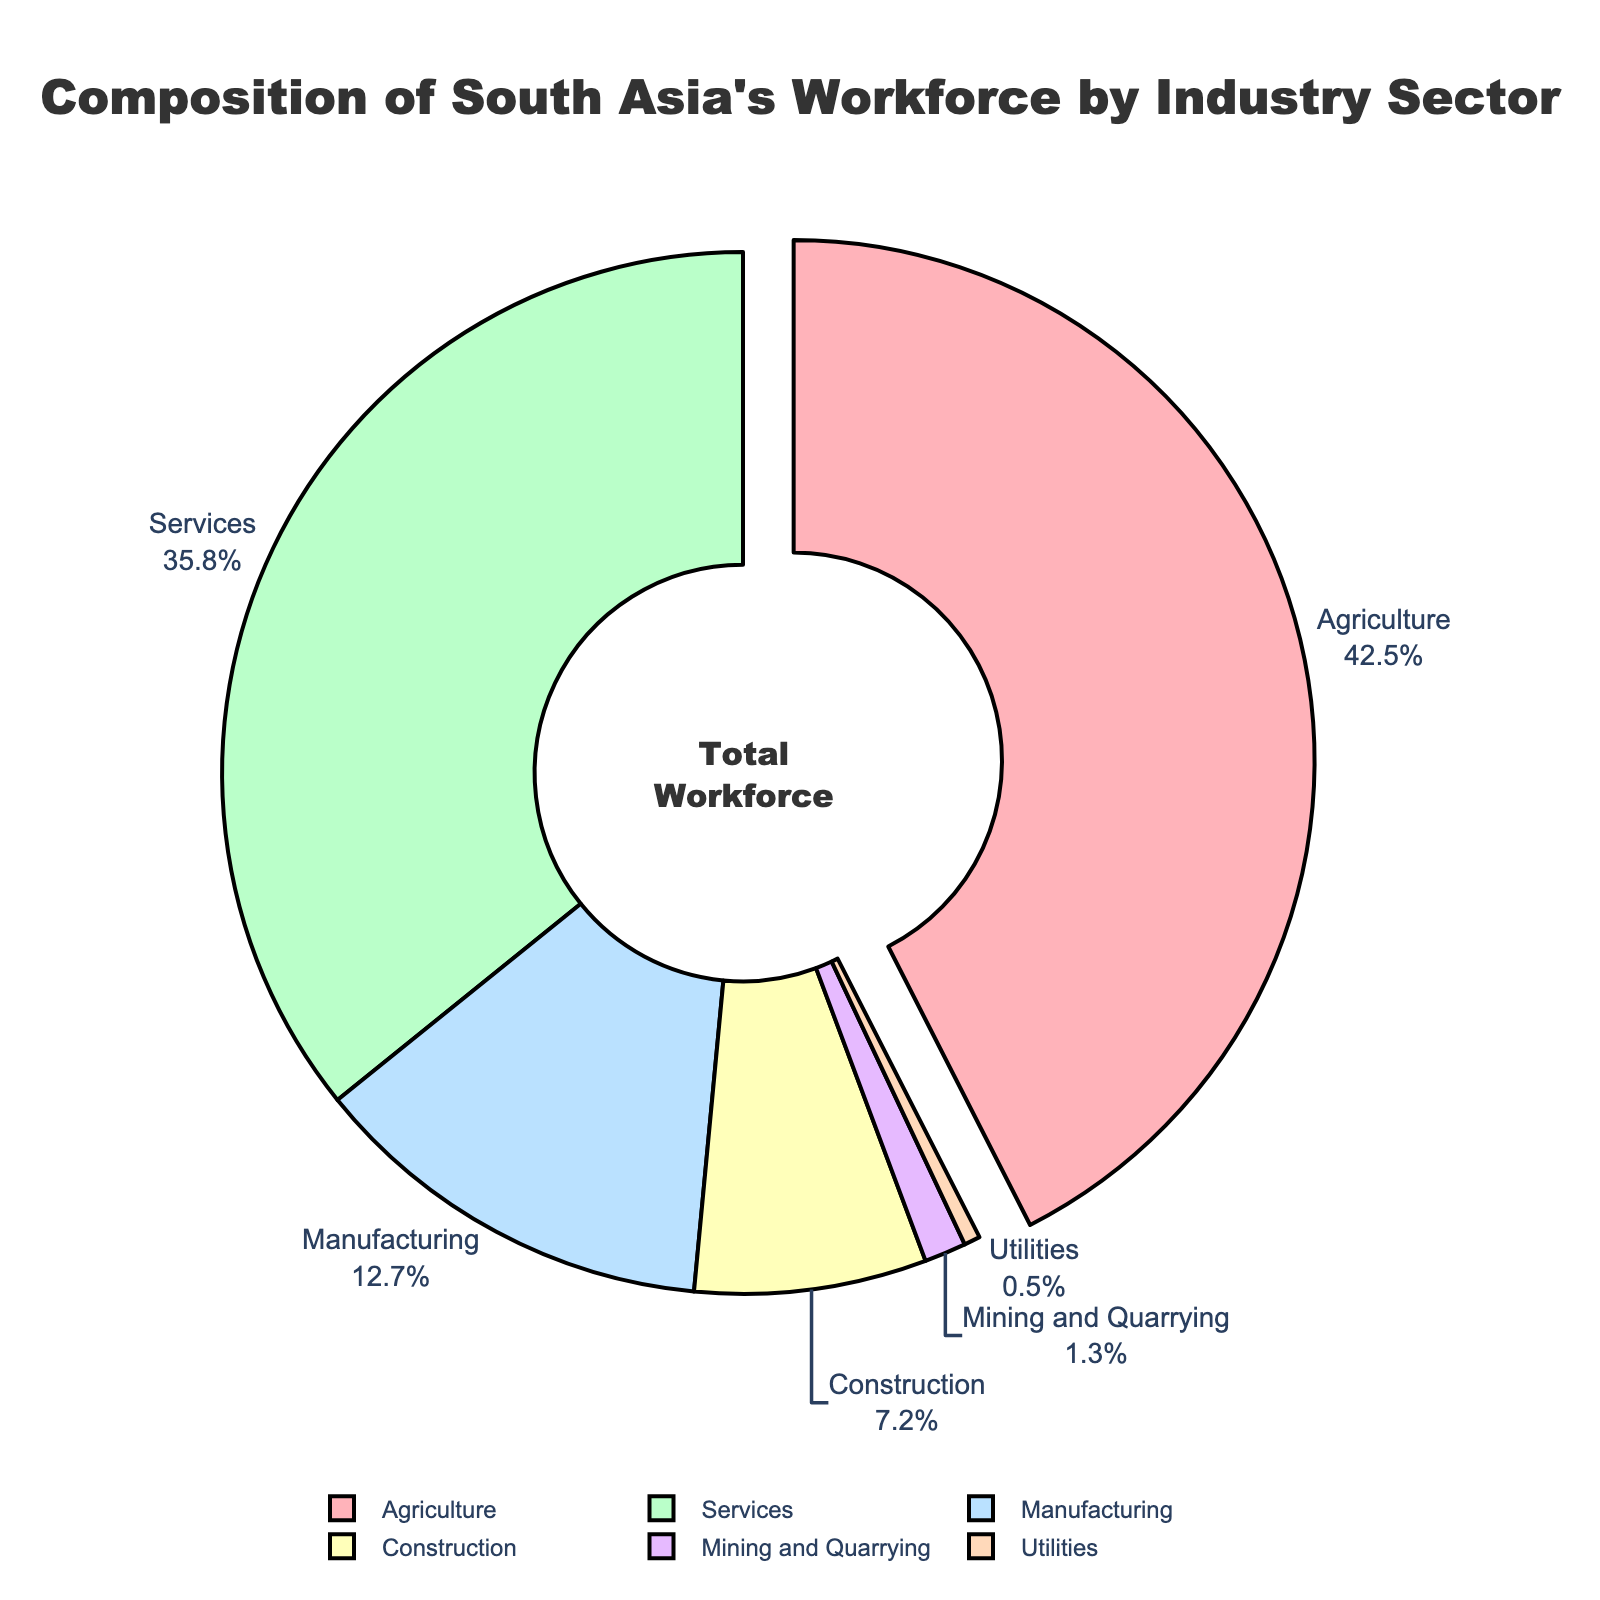What is the percentage of the workforce employed in the agriculture sector? The pie chart indicates that the agriculture sector employs 42.5% of the workforce, as displayed outside the corresponding pie segment.
Answer: 42.5% What is the combined percentage of the workforce in the services and manufacturing sectors? From the chart, the services sector employs 35.8% and the manufacturing sector employs 12.7%. The combined percentage is 35.8 + 12.7 = 48.5%.
Answer: 48.5% Which industry sector employs more people: construction or mining and quarrying? According to the chart, the construction sector employs 7.2%, while the mining and quarrying sector employs 1.3%. Therefore, construction employs more people.
Answer: Construction What is the percentage point difference between the workforce in agriculture and services sectors? The pie chart shows that agriculture employs 42.5% and services employ 35.8%. The difference is 42.5 - 35.8 = 6.7 percentage points.
Answer: 6.7 Apart from agriculture, which other industry has its slice slightly pulled out from the pie chart? Only the slice representing the agriculture sector is pulled out from the pie chart. No other industry slice is pulled out.
Answer: None Which sector is depicted with the green color? The services sector is depicted with the green color in the pie chart.
Answer: Services What percentage of the workforce is employed in sectors other than agriculture and services? First, find the combined percentage for agriculture and services: 42.5 + 35.8 = 78.3%. Now, subtract this from 100% to find the percentage working in other sectors: 100 - 78.3 = 21.7%.
Answer: 21.7% How does the percentage of the workforce in utilities compare with that in mining and quarrying? According to the chart, utilities employ 0.5% and mining and quarrying employ 1.3%. Therefore, mining and quarrying employ more people than utilities.
Answer: Mining and Quarrying Which industry sector is represented with the light purple color? The light purple color represents the mining and quarrying sector.
Answer: Mining and Quarrying What is the combined workforce percentage of sectors that employ less than 10% each? Identify the sectors: manufacturing (12.7%), construction (7.2%), mining and quarrying (1.3%), and utilities (0.5%). Combine the percentages for those employing less than 10%: 7.2 + 1.3 + 0.5 = 9%.
Answer: 9% 